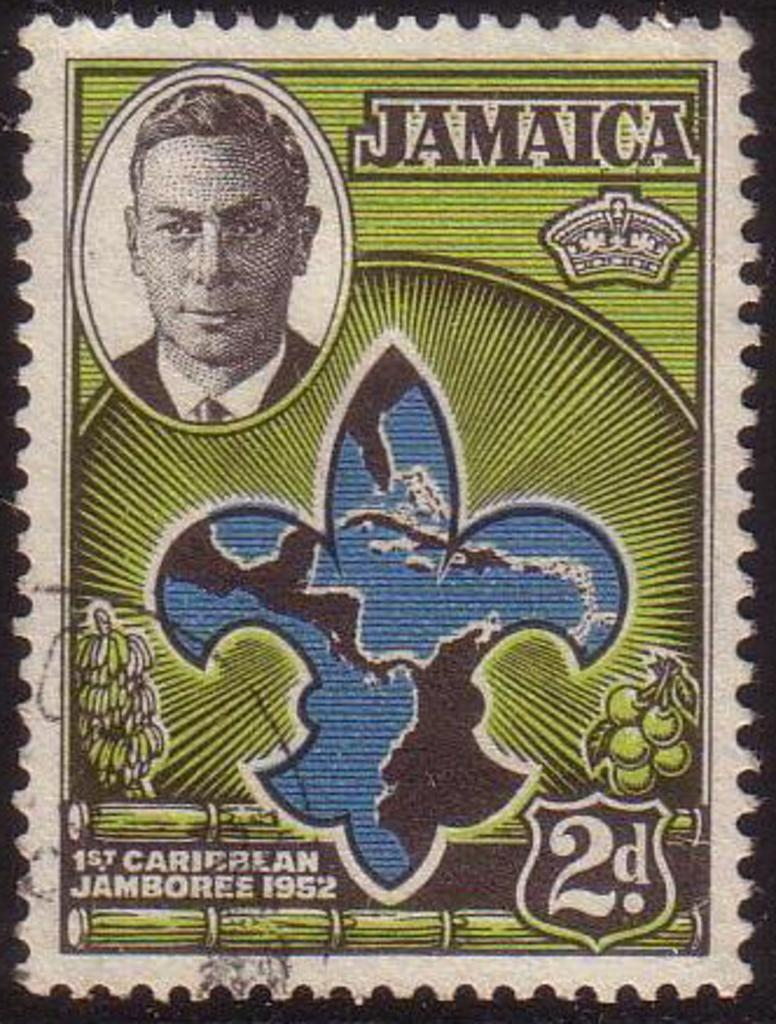What type of art form is represented in the image? The image is a paper cutting. What subject is depicted in the paper cutting? There is a man depicted in the paper cutting. Are there any words or phrases present in the paper cutting? Yes, there is text present in the paper cutting. What type of bread is being sliced in the image? There is no bread present in the image; it is a paper cutting depicting a man with text. Can you see any veins in the man's body in the image? The image is a paper cutting, and it does not show the internal anatomy of the man, so we cannot see any veins. 